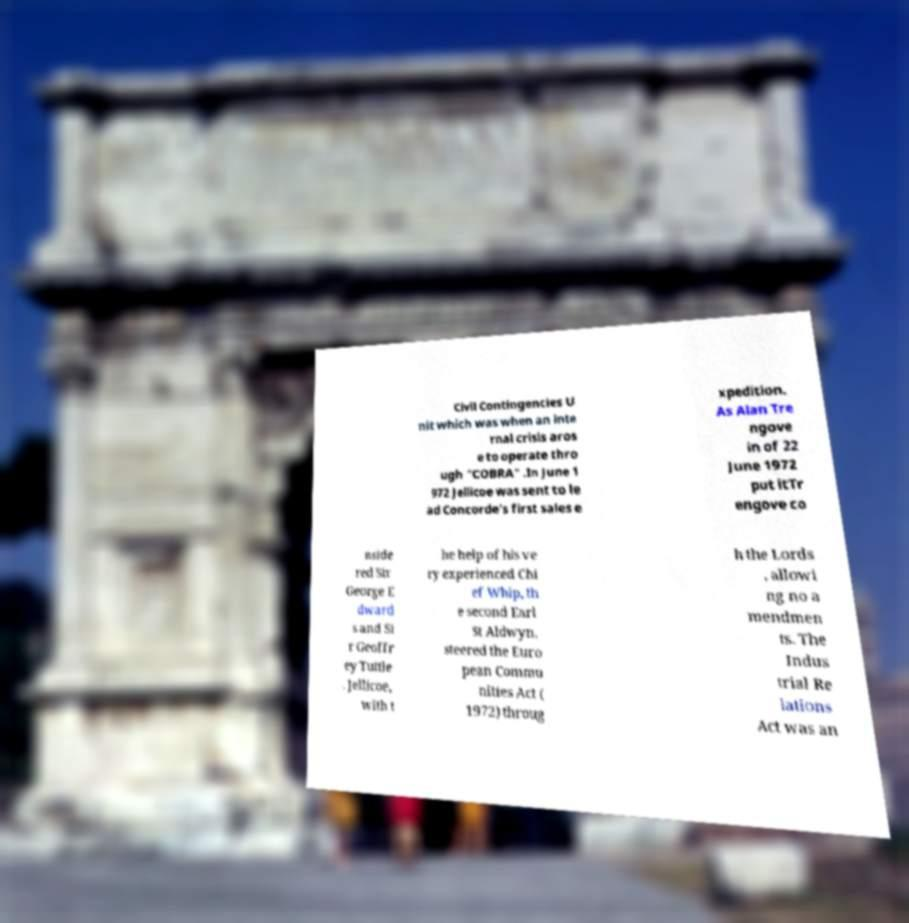Please identify and transcribe the text found in this image. Civil Contingencies U nit which was when an inte rnal crisis aros e to operate thro ugh "COBRA" .In June 1 972 Jellicoe was sent to le ad Concorde's first sales e xpedition. As Alan Tre ngove in of 22 June 1972 put itTr engove co nside red Sir George E dward s and Si r Geoffr ey Tuttle . Jellicoe, with t he help of his ve ry experienced Chi ef Whip, th e second Earl St Aldwyn, steered the Euro pean Commu nities Act ( 1972) throug h the Lords , allowi ng no a mendmen ts. The Indus trial Re lations Act was an 